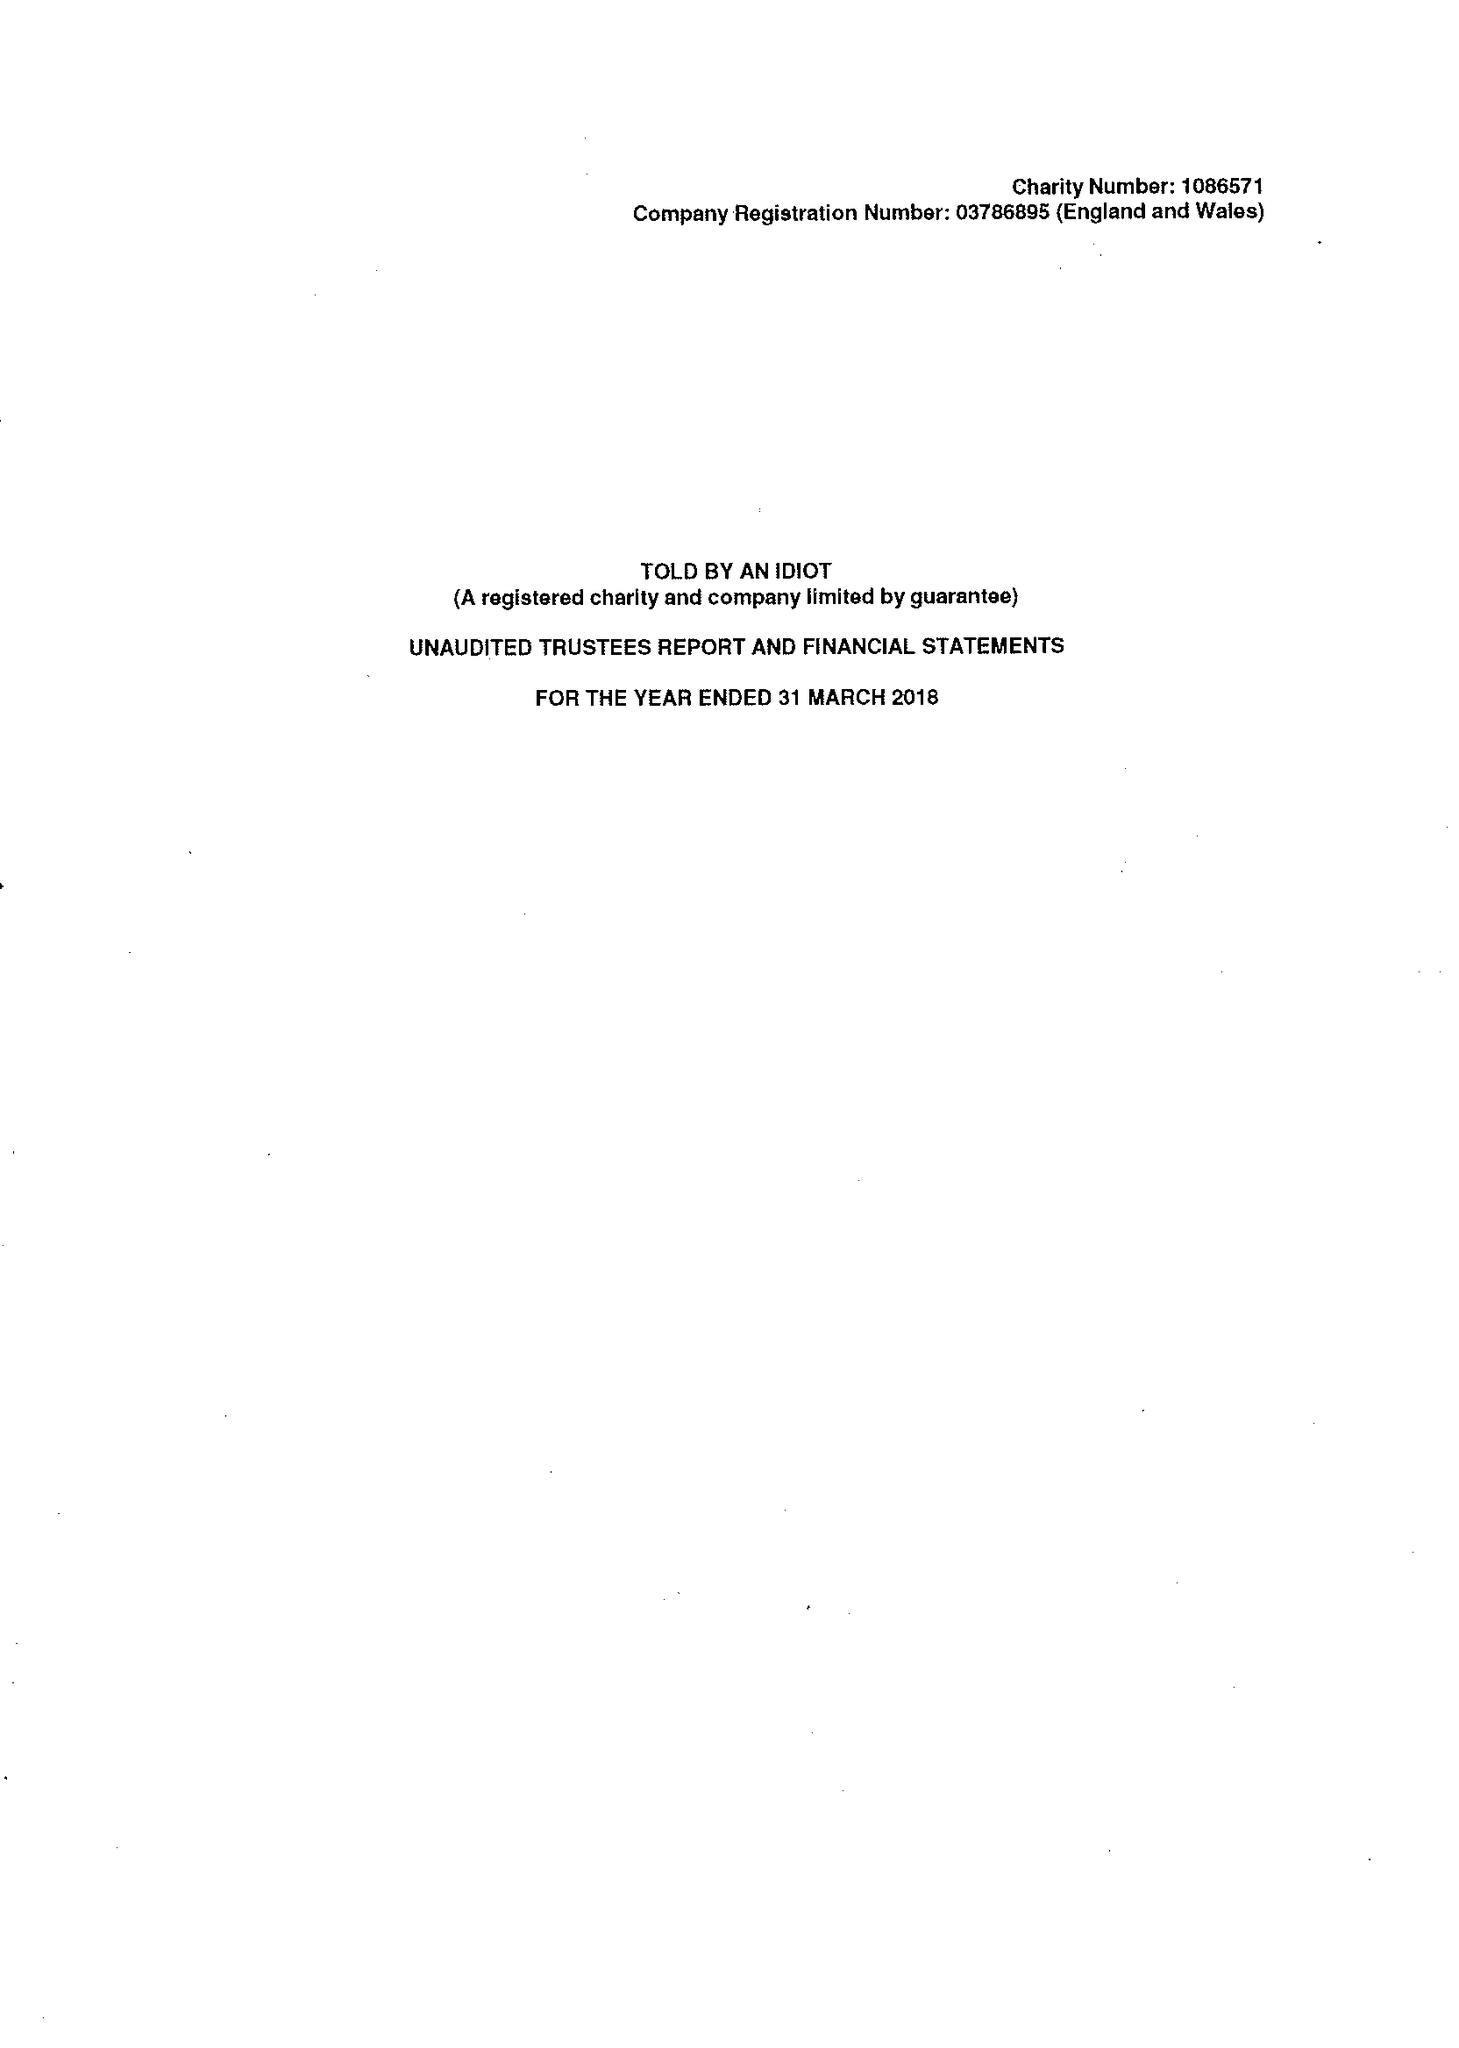What is the value for the income_annually_in_british_pounds?
Answer the question using a single word or phrase. 379561.00 